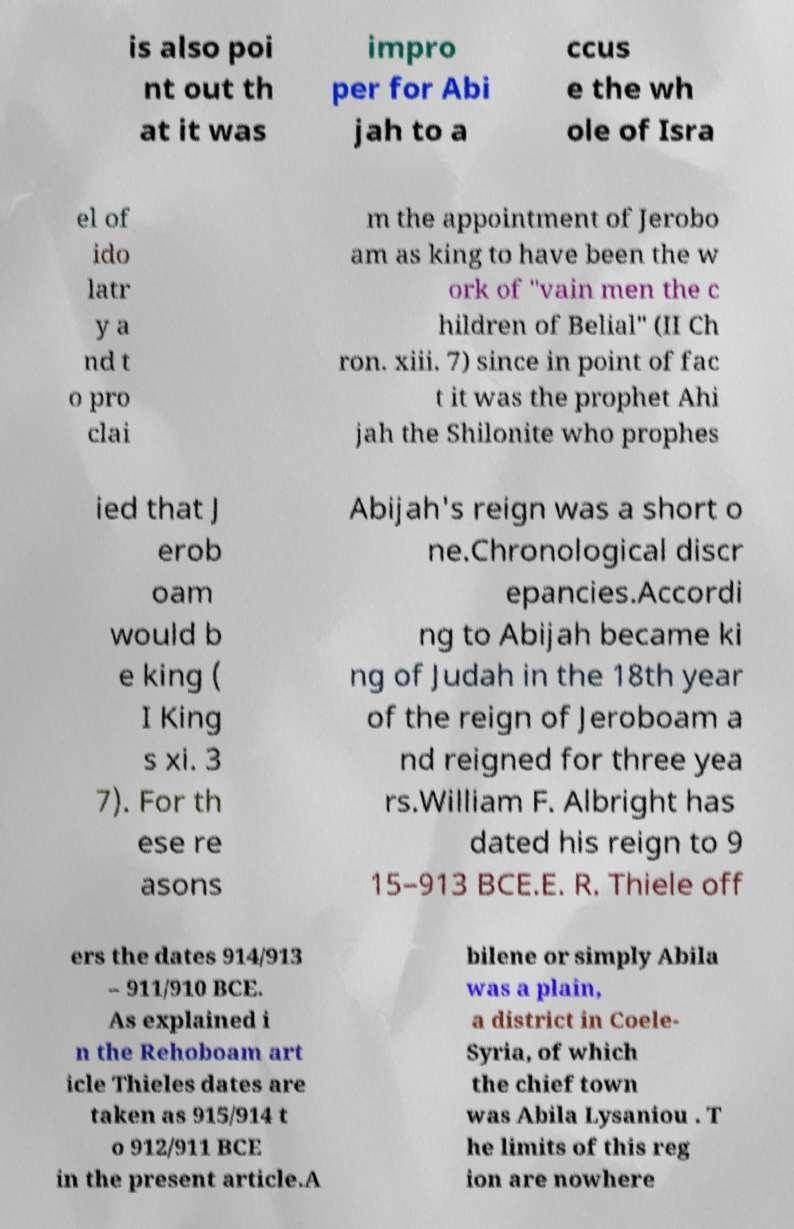What messages or text are displayed in this image? I need them in a readable, typed format. is also poi nt out th at it was impro per for Abi jah to a ccus e the wh ole of Isra el of ido latr y a nd t o pro clai m the appointment of Jerobo am as king to have been the w ork of "vain men the c hildren of Belial" (II Ch ron. xiii. 7) since in point of fac t it was the prophet Ahi jah the Shilonite who prophes ied that J erob oam would b e king ( I King s xi. 3 7). For th ese re asons Abijah's reign was a short o ne.Chronological discr epancies.Accordi ng to Abijah became ki ng of Judah in the 18th year of the reign of Jeroboam a nd reigned for three yea rs.William F. Albright has dated his reign to 9 15–913 BCE.E. R. Thiele off ers the dates 914/913 – 911/910 BCE. As explained i n the Rehoboam art icle Thieles dates are taken as 915/914 t o 912/911 BCE in the present article.A bilene or simply Abila was a plain, a district in Coele- Syria, of which the chief town was Abila Lysaniou . T he limits of this reg ion are nowhere 